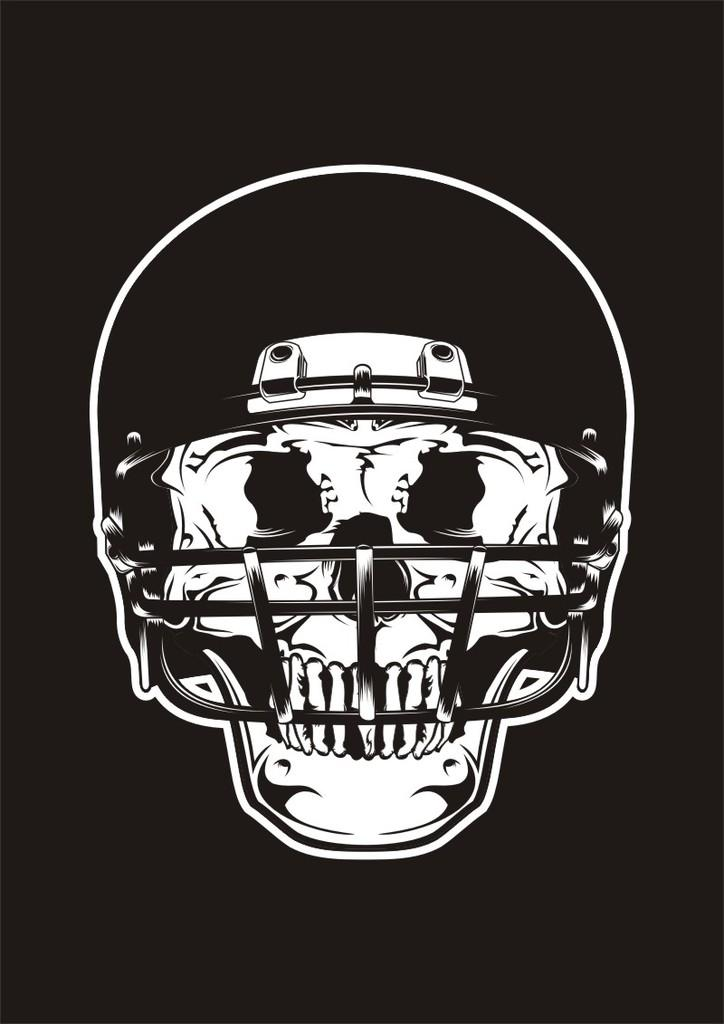What is the main subject of the image? The main subject of the image is a skull. What is the skull wearing in the image? The skull is wearing a helmet in the image. What color scheme is used in the image? The image is in black and white color. What type of connection can be seen between the brass vessel and the skull in the image? There is no brass vessel or any connection between objects in the image; it only features a skull wearing a helmet in black and white color. 